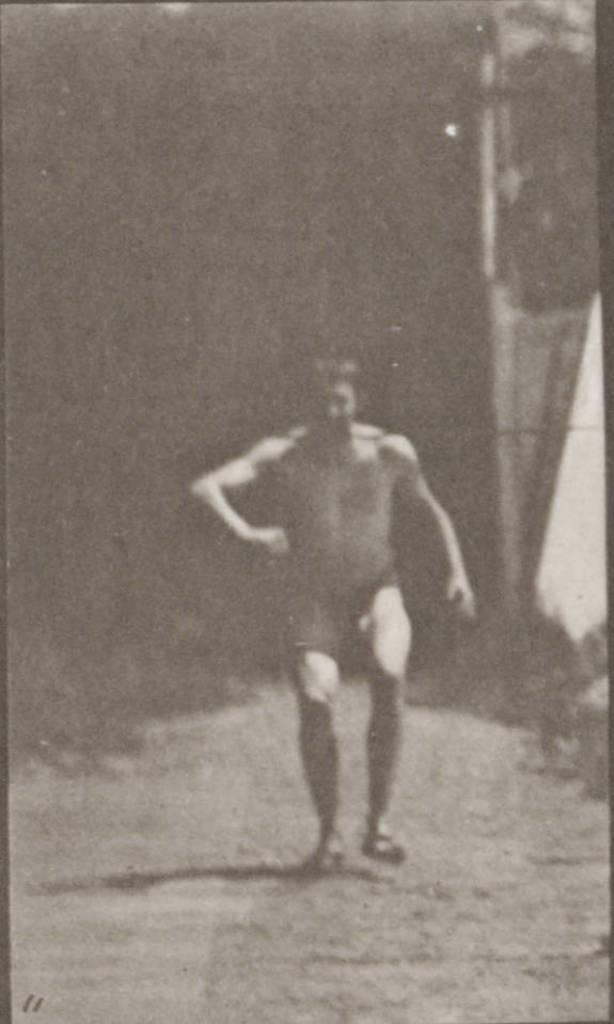What is the color scheme of the image? The image is black and white. Can you describe the main subject in the image? There is a person in the image. What is located behind the person in the image? There is a wall behind the person in the image. What type of flooring can be seen beneath the person in the image? The image is black and white, and there is no information about the flooring. Therefore, it cannot be determined from the image. 